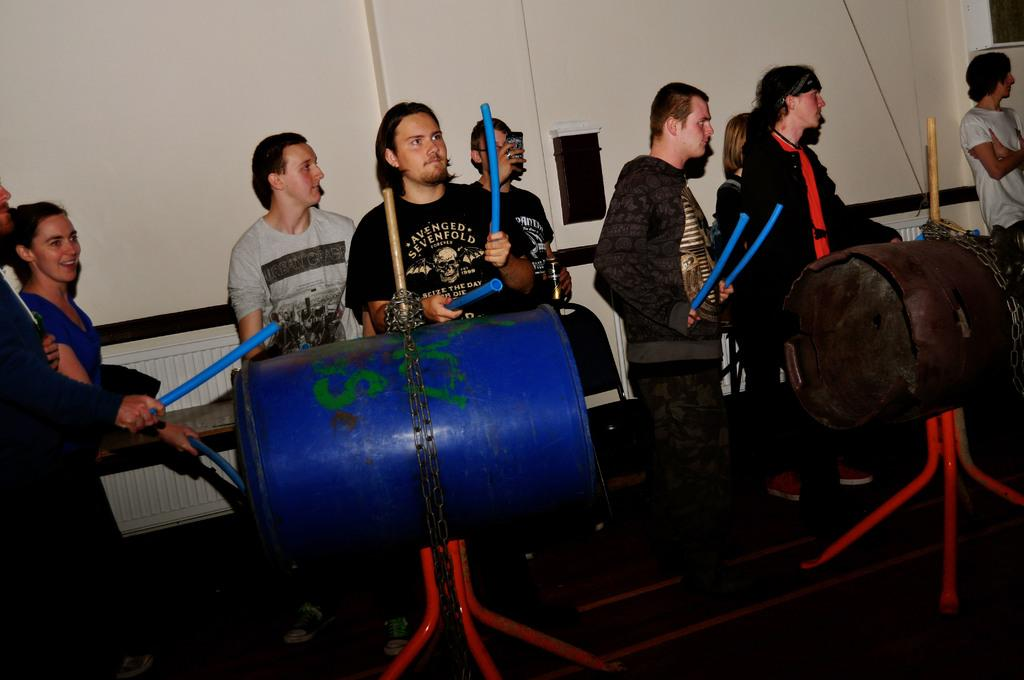What are the people in the image doing? The people in the image are standing and holding sticks. What objects can be seen near the people? There are barrels with chains in the image. What structures are present in the background of the image? There are stands, a wall, chairs, and a window in the background of the image. What type of hen can be seen conducting a science experiment in the image? There is no hen or science experiment present in the image. How does the behavior of the people in the image change when they see the window? The provided facts do not mention any change in behavior when the people see the window. 